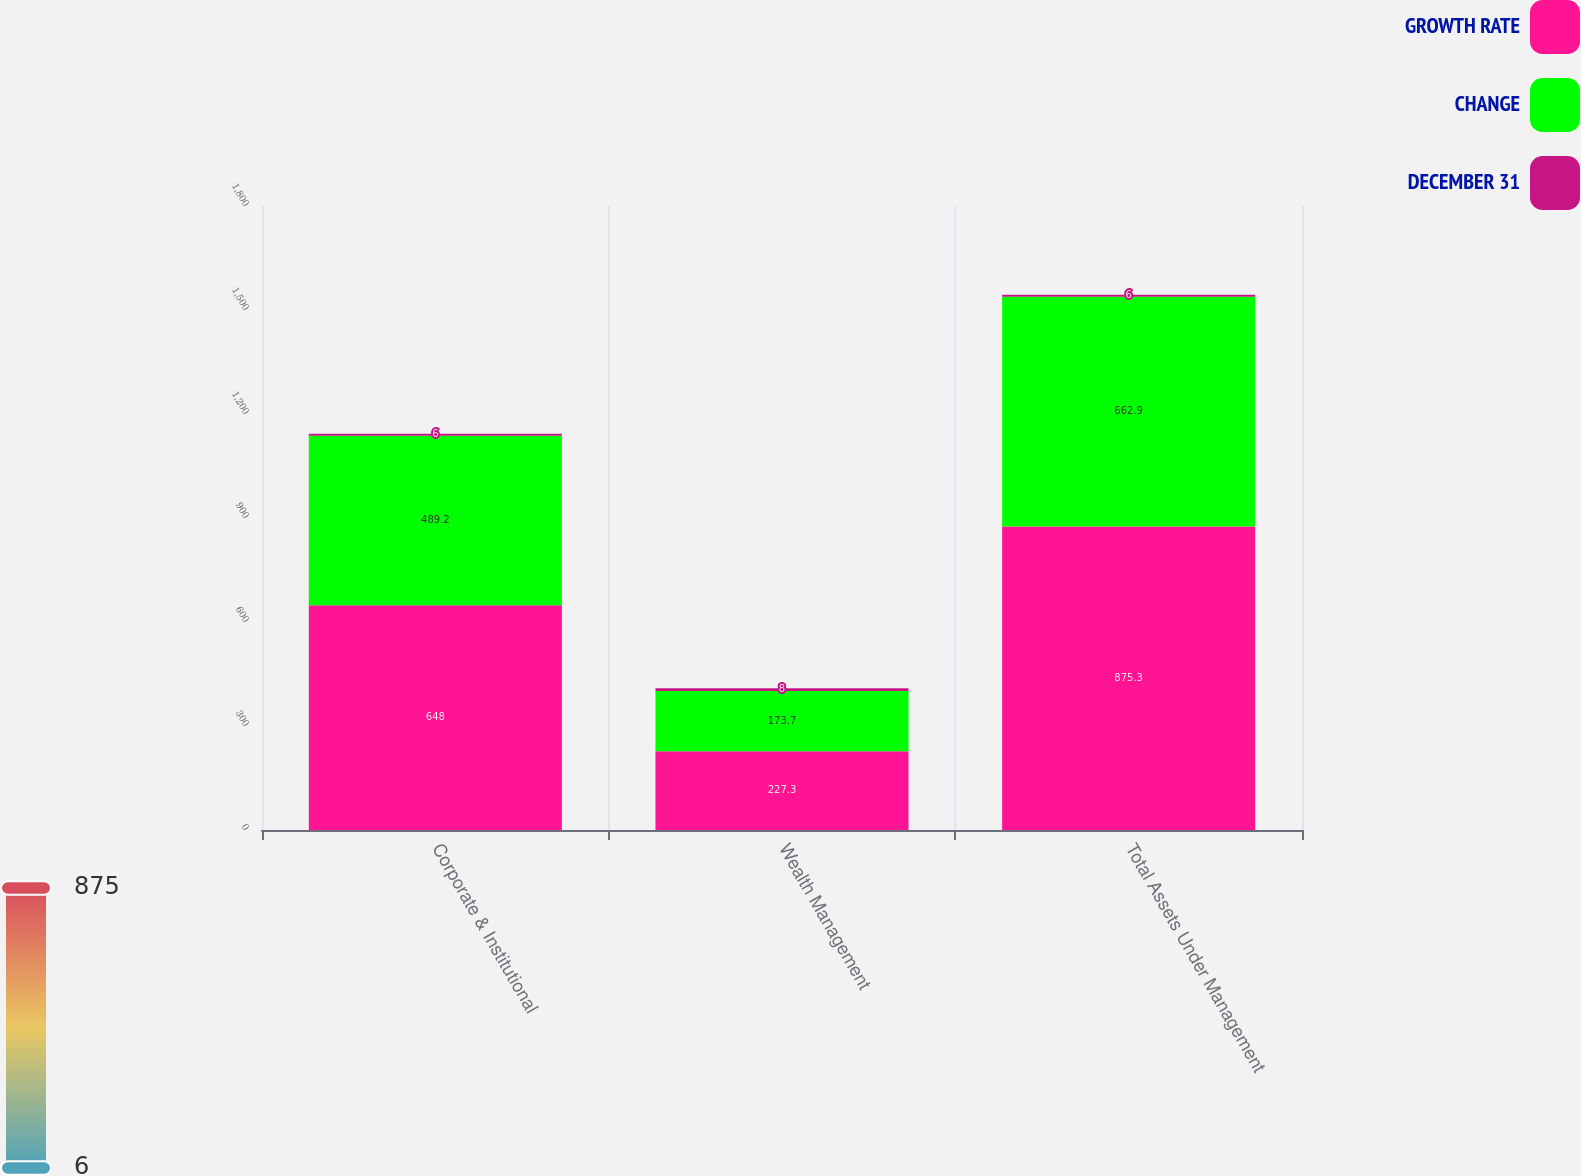Convert chart. <chart><loc_0><loc_0><loc_500><loc_500><stacked_bar_chart><ecel><fcel>Corporate & Institutional<fcel>Wealth Management<fcel>Total Assets Under Management<nl><fcel>GROWTH RATE<fcel>648<fcel>227.3<fcel>875.3<nl><fcel>CHANGE<fcel>489.2<fcel>173.7<fcel>662.9<nl><fcel>DECEMBER 31<fcel>6<fcel>8<fcel>6<nl></chart> 